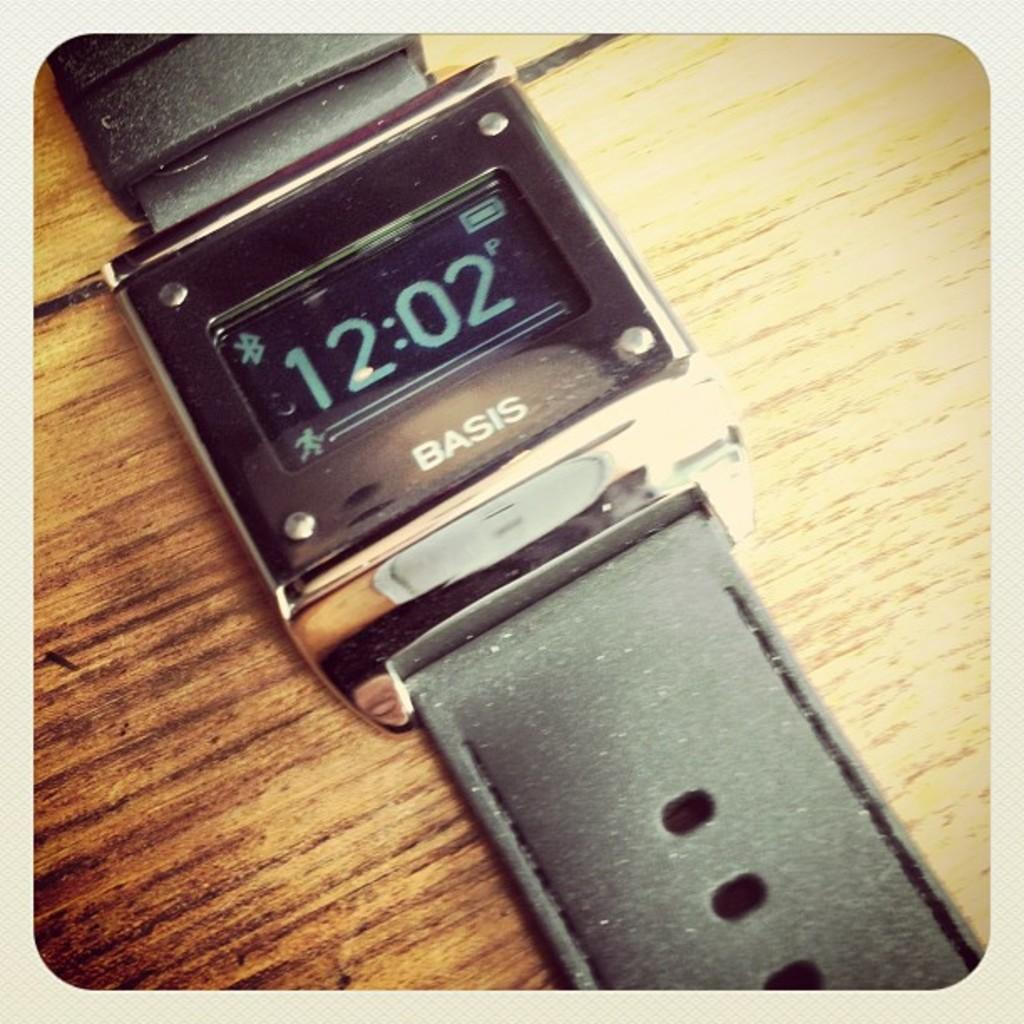<image>
Share a concise interpretation of the image provided. A Basis watch shows the time as 12:02, 